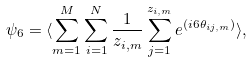Convert formula to latex. <formula><loc_0><loc_0><loc_500><loc_500>\psi _ { 6 } = \langle \sum _ { m = 1 } ^ { M } \sum _ { i = 1 } ^ { N } \frac { 1 } { z _ { i , m } } \sum _ { j = 1 } ^ { z _ { i , m } } e ^ { ( i 6 \theta _ { i j , m } ) } \rangle ,</formula> 